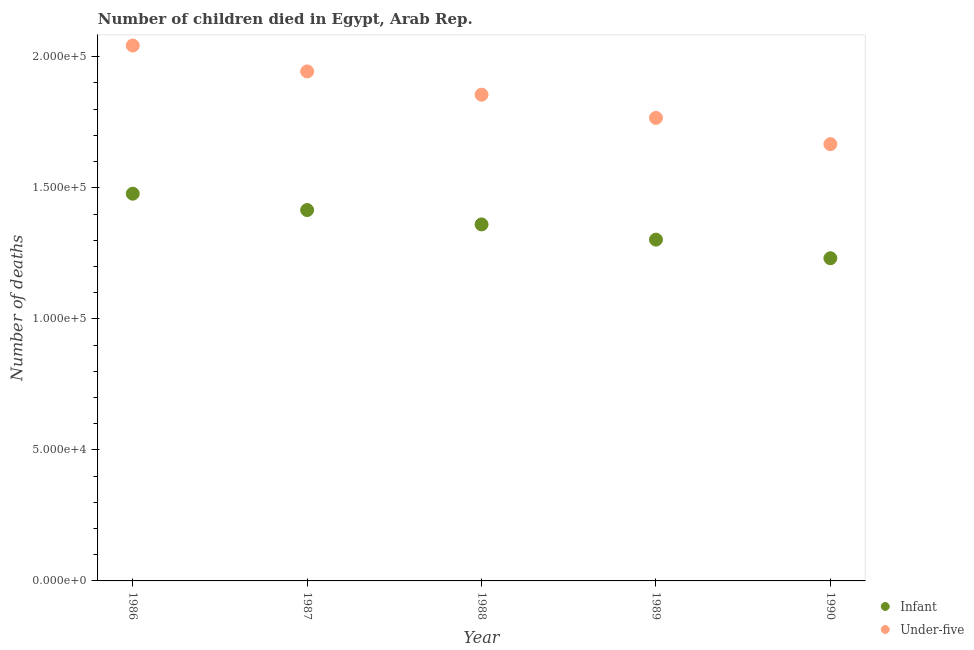What is the number of under-five deaths in 1989?
Keep it short and to the point. 1.77e+05. Across all years, what is the maximum number of under-five deaths?
Your response must be concise. 2.04e+05. Across all years, what is the minimum number of under-five deaths?
Give a very brief answer. 1.67e+05. What is the total number of infant deaths in the graph?
Your answer should be compact. 6.79e+05. What is the difference between the number of under-five deaths in 1989 and that in 1990?
Offer a very short reply. 1.00e+04. What is the difference between the number of infant deaths in 1988 and the number of under-five deaths in 1986?
Make the answer very short. -6.83e+04. What is the average number of infant deaths per year?
Give a very brief answer. 1.36e+05. In the year 1988, what is the difference between the number of infant deaths and number of under-five deaths?
Your answer should be compact. -4.95e+04. In how many years, is the number of infant deaths greater than 150000?
Keep it short and to the point. 0. What is the ratio of the number of infant deaths in 1986 to that in 1990?
Provide a short and direct response. 1.2. Is the number of infant deaths in 1987 less than that in 1988?
Make the answer very short. No. What is the difference between the highest and the second highest number of under-five deaths?
Ensure brevity in your answer.  9883. What is the difference between the highest and the lowest number of infant deaths?
Keep it short and to the point. 2.46e+04. Does the number of under-five deaths monotonically increase over the years?
Provide a succinct answer. No. How many dotlines are there?
Provide a short and direct response. 2. How many years are there in the graph?
Keep it short and to the point. 5. What is the difference between two consecutive major ticks on the Y-axis?
Offer a very short reply. 5.00e+04. Does the graph contain any zero values?
Offer a very short reply. No. How many legend labels are there?
Your response must be concise. 2. How are the legend labels stacked?
Make the answer very short. Vertical. What is the title of the graph?
Ensure brevity in your answer.  Number of children died in Egypt, Arab Rep. Does "Register a business" appear as one of the legend labels in the graph?
Provide a short and direct response. No. What is the label or title of the X-axis?
Your answer should be compact. Year. What is the label or title of the Y-axis?
Your answer should be compact. Number of deaths. What is the Number of deaths of Infant in 1986?
Your answer should be compact. 1.48e+05. What is the Number of deaths of Under-five in 1986?
Keep it short and to the point. 2.04e+05. What is the Number of deaths of Infant in 1987?
Provide a short and direct response. 1.42e+05. What is the Number of deaths of Under-five in 1987?
Your answer should be compact. 1.94e+05. What is the Number of deaths in Infant in 1988?
Offer a terse response. 1.36e+05. What is the Number of deaths of Under-five in 1988?
Your answer should be very brief. 1.86e+05. What is the Number of deaths in Infant in 1989?
Keep it short and to the point. 1.30e+05. What is the Number of deaths in Under-five in 1989?
Give a very brief answer. 1.77e+05. What is the Number of deaths of Infant in 1990?
Offer a terse response. 1.23e+05. What is the Number of deaths of Under-five in 1990?
Provide a short and direct response. 1.67e+05. Across all years, what is the maximum Number of deaths in Infant?
Your answer should be compact. 1.48e+05. Across all years, what is the maximum Number of deaths of Under-five?
Give a very brief answer. 2.04e+05. Across all years, what is the minimum Number of deaths of Infant?
Offer a terse response. 1.23e+05. Across all years, what is the minimum Number of deaths of Under-five?
Give a very brief answer. 1.67e+05. What is the total Number of deaths in Infant in the graph?
Make the answer very short. 6.79e+05. What is the total Number of deaths in Under-five in the graph?
Offer a very short reply. 9.28e+05. What is the difference between the Number of deaths of Infant in 1986 and that in 1987?
Offer a terse response. 6238. What is the difference between the Number of deaths of Under-five in 1986 and that in 1987?
Offer a very short reply. 9883. What is the difference between the Number of deaths of Infant in 1986 and that in 1988?
Your answer should be very brief. 1.17e+04. What is the difference between the Number of deaths in Under-five in 1986 and that in 1988?
Your response must be concise. 1.88e+04. What is the difference between the Number of deaths of Infant in 1986 and that in 1989?
Keep it short and to the point. 1.75e+04. What is the difference between the Number of deaths in Under-five in 1986 and that in 1989?
Offer a very short reply. 2.76e+04. What is the difference between the Number of deaths of Infant in 1986 and that in 1990?
Give a very brief answer. 2.46e+04. What is the difference between the Number of deaths in Under-five in 1986 and that in 1990?
Keep it short and to the point. 3.76e+04. What is the difference between the Number of deaths in Infant in 1987 and that in 1988?
Make the answer very short. 5482. What is the difference between the Number of deaths of Under-five in 1987 and that in 1988?
Ensure brevity in your answer.  8878. What is the difference between the Number of deaths in Infant in 1987 and that in 1989?
Keep it short and to the point. 1.13e+04. What is the difference between the Number of deaths of Under-five in 1987 and that in 1989?
Offer a terse response. 1.77e+04. What is the difference between the Number of deaths in Infant in 1987 and that in 1990?
Give a very brief answer. 1.84e+04. What is the difference between the Number of deaths in Under-five in 1987 and that in 1990?
Your answer should be very brief. 2.78e+04. What is the difference between the Number of deaths of Infant in 1988 and that in 1989?
Offer a very short reply. 5802. What is the difference between the Number of deaths of Under-five in 1988 and that in 1989?
Provide a short and direct response. 8860. What is the difference between the Number of deaths of Infant in 1988 and that in 1990?
Ensure brevity in your answer.  1.29e+04. What is the difference between the Number of deaths of Under-five in 1988 and that in 1990?
Offer a very short reply. 1.89e+04. What is the difference between the Number of deaths of Infant in 1989 and that in 1990?
Give a very brief answer. 7101. What is the difference between the Number of deaths in Under-five in 1989 and that in 1990?
Offer a very short reply. 1.00e+04. What is the difference between the Number of deaths of Infant in 1986 and the Number of deaths of Under-five in 1987?
Ensure brevity in your answer.  -4.67e+04. What is the difference between the Number of deaths in Infant in 1986 and the Number of deaths in Under-five in 1988?
Ensure brevity in your answer.  -3.78e+04. What is the difference between the Number of deaths in Infant in 1986 and the Number of deaths in Under-five in 1989?
Ensure brevity in your answer.  -2.89e+04. What is the difference between the Number of deaths in Infant in 1986 and the Number of deaths in Under-five in 1990?
Your answer should be compact. -1.89e+04. What is the difference between the Number of deaths of Infant in 1987 and the Number of deaths of Under-five in 1988?
Provide a succinct answer. -4.40e+04. What is the difference between the Number of deaths of Infant in 1987 and the Number of deaths of Under-five in 1989?
Your response must be concise. -3.52e+04. What is the difference between the Number of deaths of Infant in 1987 and the Number of deaths of Under-five in 1990?
Your answer should be compact. -2.51e+04. What is the difference between the Number of deaths of Infant in 1988 and the Number of deaths of Under-five in 1989?
Offer a very short reply. -4.06e+04. What is the difference between the Number of deaths in Infant in 1988 and the Number of deaths in Under-five in 1990?
Keep it short and to the point. -3.06e+04. What is the difference between the Number of deaths of Infant in 1989 and the Number of deaths of Under-five in 1990?
Your answer should be very brief. -3.64e+04. What is the average Number of deaths of Infant per year?
Your answer should be very brief. 1.36e+05. What is the average Number of deaths in Under-five per year?
Make the answer very short. 1.86e+05. In the year 1986, what is the difference between the Number of deaths of Infant and Number of deaths of Under-five?
Provide a short and direct response. -5.65e+04. In the year 1987, what is the difference between the Number of deaths in Infant and Number of deaths in Under-five?
Ensure brevity in your answer.  -5.29e+04. In the year 1988, what is the difference between the Number of deaths of Infant and Number of deaths of Under-five?
Provide a short and direct response. -4.95e+04. In the year 1989, what is the difference between the Number of deaths in Infant and Number of deaths in Under-five?
Your answer should be very brief. -4.64e+04. In the year 1990, what is the difference between the Number of deaths of Infant and Number of deaths of Under-five?
Provide a succinct answer. -4.35e+04. What is the ratio of the Number of deaths in Infant in 1986 to that in 1987?
Ensure brevity in your answer.  1.04. What is the ratio of the Number of deaths in Under-five in 1986 to that in 1987?
Give a very brief answer. 1.05. What is the ratio of the Number of deaths in Infant in 1986 to that in 1988?
Your answer should be very brief. 1.09. What is the ratio of the Number of deaths in Under-five in 1986 to that in 1988?
Provide a succinct answer. 1.1. What is the ratio of the Number of deaths of Infant in 1986 to that in 1989?
Your answer should be compact. 1.13. What is the ratio of the Number of deaths of Under-five in 1986 to that in 1989?
Your answer should be compact. 1.16. What is the ratio of the Number of deaths in Infant in 1986 to that in 1990?
Give a very brief answer. 1.2. What is the ratio of the Number of deaths of Under-five in 1986 to that in 1990?
Offer a very short reply. 1.23. What is the ratio of the Number of deaths of Infant in 1987 to that in 1988?
Offer a very short reply. 1.04. What is the ratio of the Number of deaths in Under-five in 1987 to that in 1988?
Make the answer very short. 1.05. What is the ratio of the Number of deaths in Infant in 1987 to that in 1989?
Provide a short and direct response. 1.09. What is the ratio of the Number of deaths of Under-five in 1987 to that in 1989?
Offer a terse response. 1.1. What is the ratio of the Number of deaths in Infant in 1987 to that in 1990?
Keep it short and to the point. 1.15. What is the ratio of the Number of deaths of Under-five in 1987 to that in 1990?
Provide a short and direct response. 1.17. What is the ratio of the Number of deaths of Infant in 1988 to that in 1989?
Offer a very short reply. 1.04. What is the ratio of the Number of deaths in Under-five in 1988 to that in 1989?
Ensure brevity in your answer.  1.05. What is the ratio of the Number of deaths in Infant in 1988 to that in 1990?
Offer a terse response. 1.1. What is the ratio of the Number of deaths of Under-five in 1988 to that in 1990?
Keep it short and to the point. 1.11. What is the ratio of the Number of deaths of Infant in 1989 to that in 1990?
Your response must be concise. 1.06. What is the ratio of the Number of deaths in Under-five in 1989 to that in 1990?
Provide a short and direct response. 1.06. What is the difference between the highest and the second highest Number of deaths in Infant?
Keep it short and to the point. 6238. What is the difference between the highest and the second highest Number of deaths in Under-five?
Provide a succinct answer. 9883. What is the difference between the highest and the lowest Number of deaths in Infant?
Give a very brief answer. 2.46e+04. What is the difference between the highest and the lowest Number of deaths of Under-five?
Provide a short and direct response. 3.76e+04. 